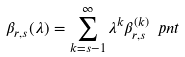<formula> <loc_0><loc_0><loc_500><loc_500>\beta _ { r , s } ( \lambda ) = \sum _ { k = s - 1 } ^ { \infty } \lambda ^ { k } \beta _ { r , s } ^ { ( k ) } \ p n t</formula> 